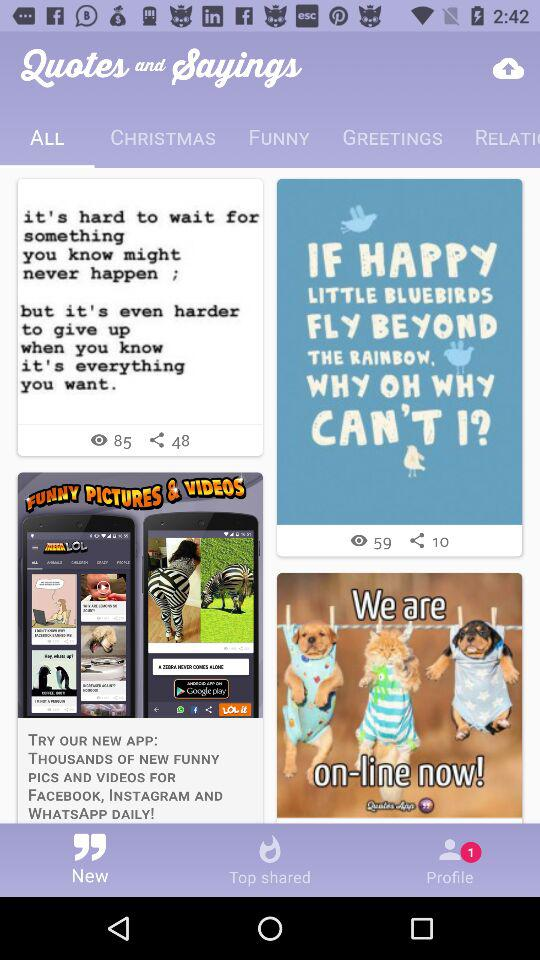How many unread messages are there?
When the provided information is insufficient, respond with <no answer>. <no answer> 